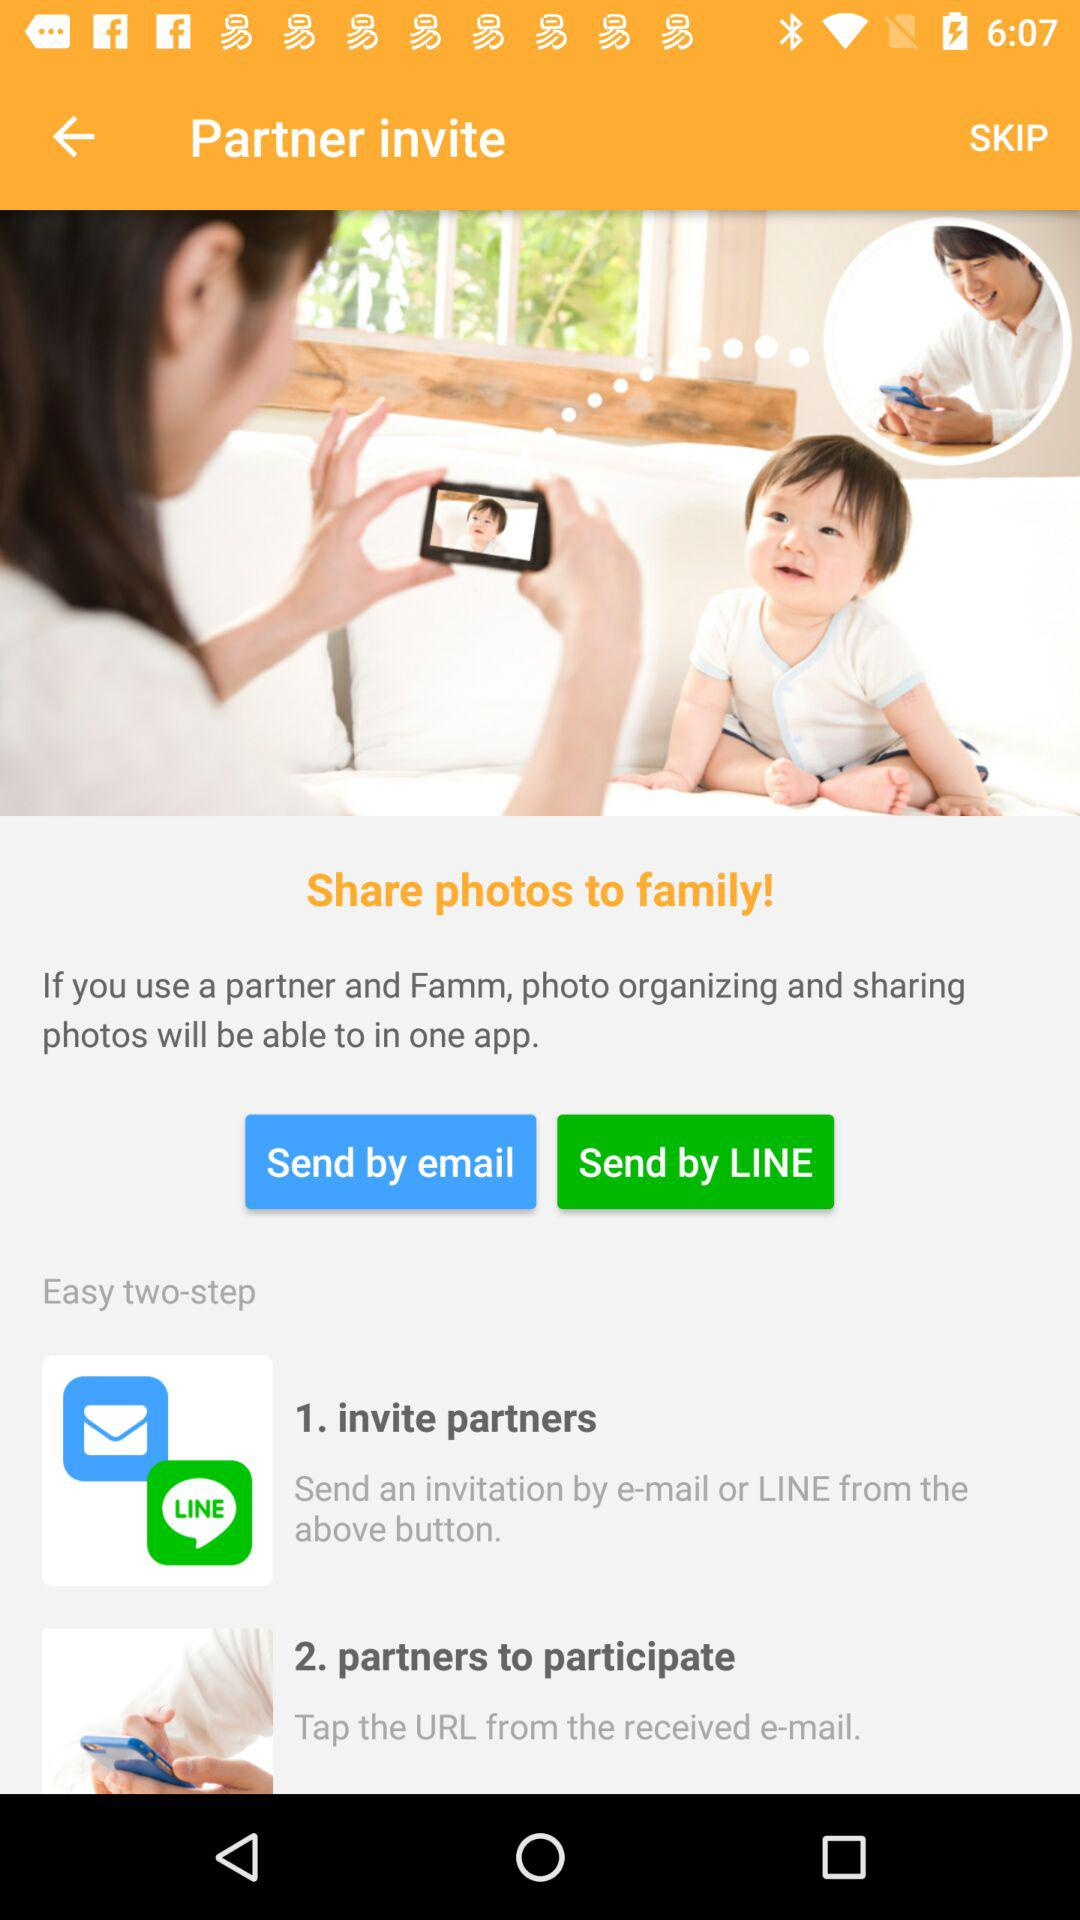What is the application name?
When the provided information is insufficient, respond with <no answer>. <no answer> 